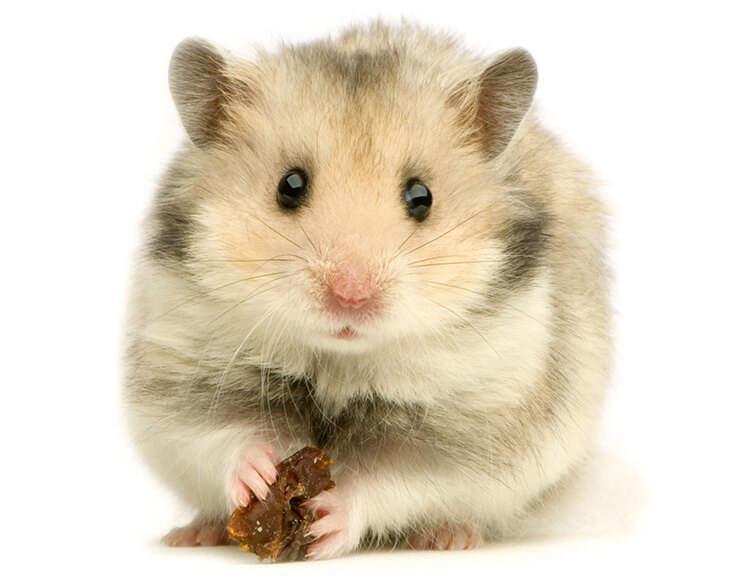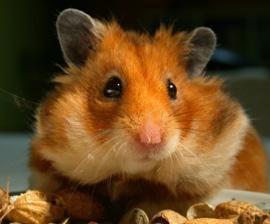The first image is the image on the left, the second image is the image on the right. Considering the images on both sides, is "The hamster in the left image is inside a bowl, and the hamster on the right is next to a bowl filled with pet food." valid? Answer yes or no. No. The first image is the image on the left, the second image is the image on the right. Analyze the images presented: Is the assertion "In the image on the left an animal is sitting in a bowl." valid? Answer yes or no. No. 